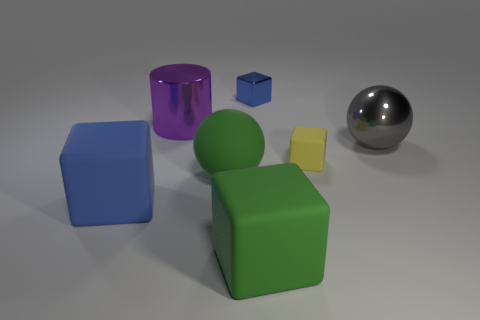There is a large thing that is the same color as the large matte sphere; what shape is it?
Offer a very short reply. Cube. There is a gray metal object; is it the same size as the blue thing right of the large green matte ball?
Provide a succinct answer. No. Do the purple cylinder and the gray ball have the same material?
Your response must be concise. Yes. Is there a purple cylinder made of the same material as the gray object?
Make the answer very short. Yes. What is the color of the metal cube?
Offer a terse response. Blue. There is a blue thing left of the small blue metal object; what size is it?
Your response must be concise. Large. What number of big objects have the same color as the tiny metal block?
Give a very brief answer. 1. There is a matte block that is in front of the blue rubber cube; are there any blocks in front of it?
Your answer should be very brief. No. There is a tiny object that is behind the gray ball; is it the same color as the rubber cube that is left of the green block?
Provide a succinct answer. Yes. What color is the metal sphere that is the same size as the cylinder?
Offer a very short reply. Gray. 